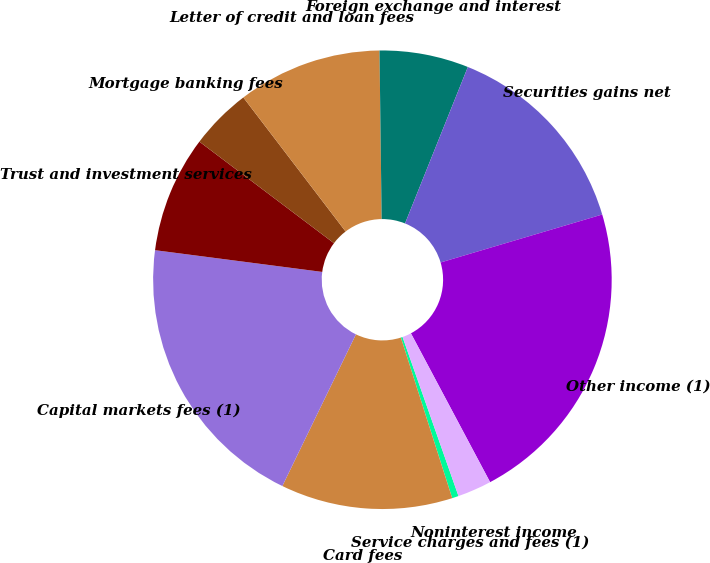<chart> <loc_0><loc_0><loc_500><loc_500><pie_chart><fcel>Service charges and fees (1)<fcel>Card fees<fcel>Capital markets fees (1)<fcel>Trust and investment services<fcel>Mortgage banking fees<fcel>Letter of credit and loan fees<fcel>Foreign exchange and interest<fcel>Securities gains net<fcel>Other income (1)<fcel>Noninterest income<nl><fcel>0.46%<fcel>12.11%<fcel>19.87%<fcel>8.23%<fcel>4.34%<fcel>10.17%<fcel>6.28%<fcel>14.33%<fcel>21.81%<fcel>2.4%<nl></chart> 